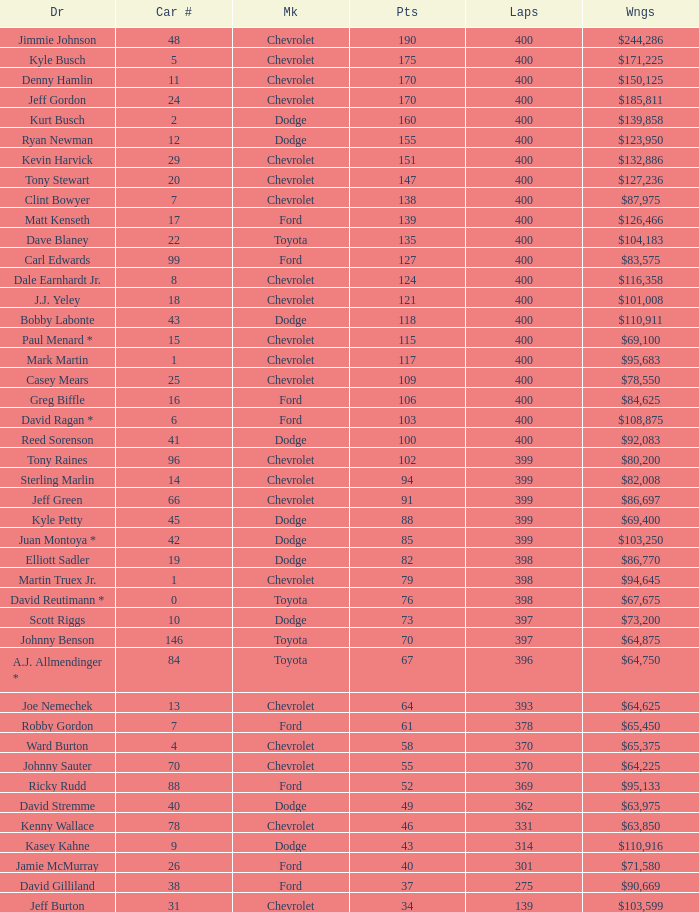What were the winnings for the Chevrolet with a number larger than 29 and scored 102 points? $80,200. 